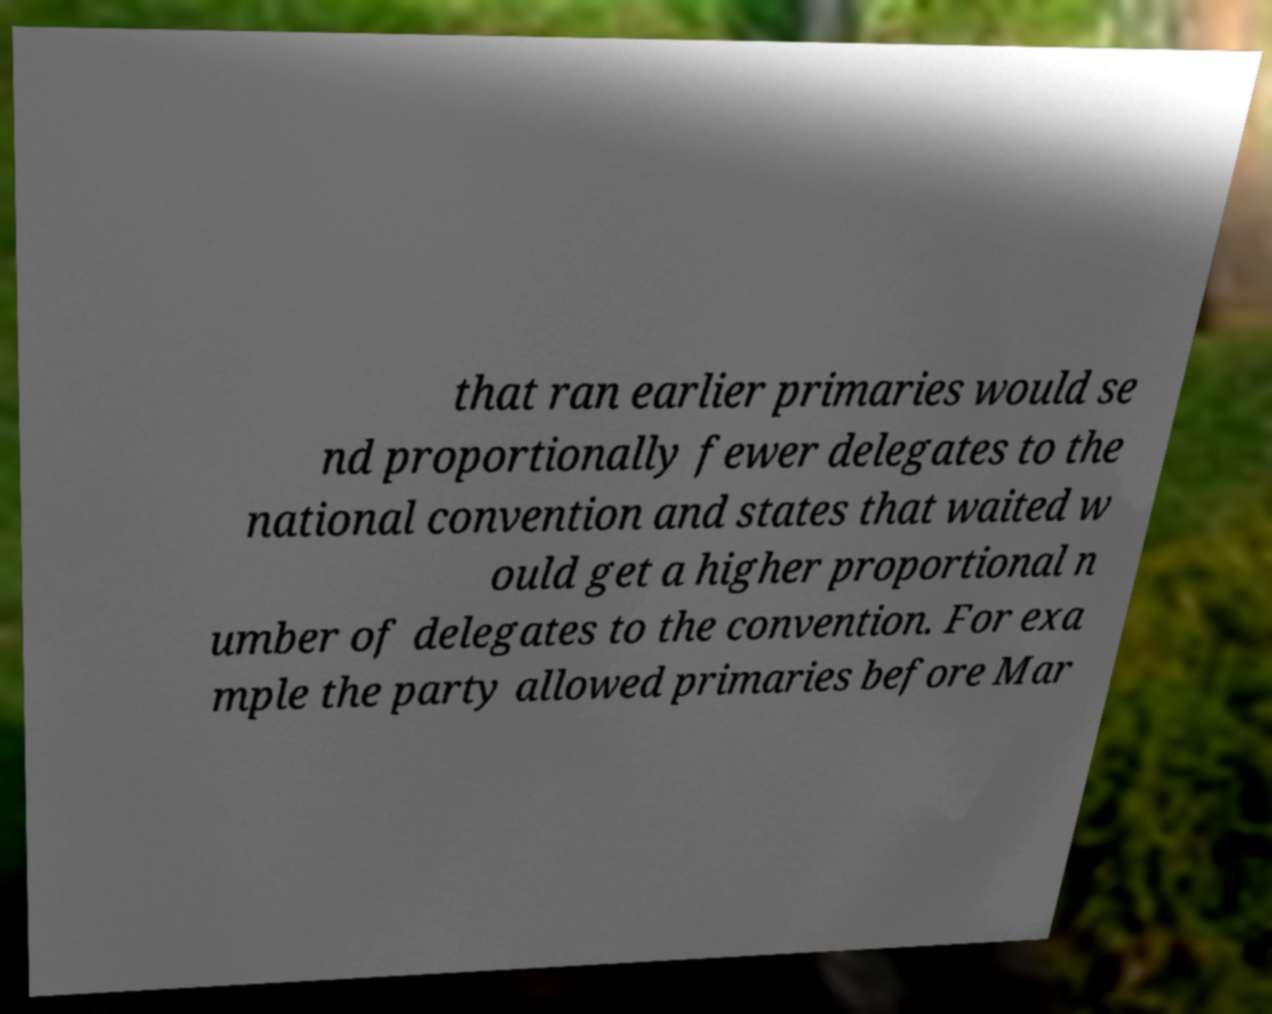Could you extract and type out the text from this image? that ran earlier primaries would se nd proportionally fewer delegates to the national convention and states that waited w ould get a higher proportional n umber of delegates to the convention. For exa mple the party allowed primaries before Mar 